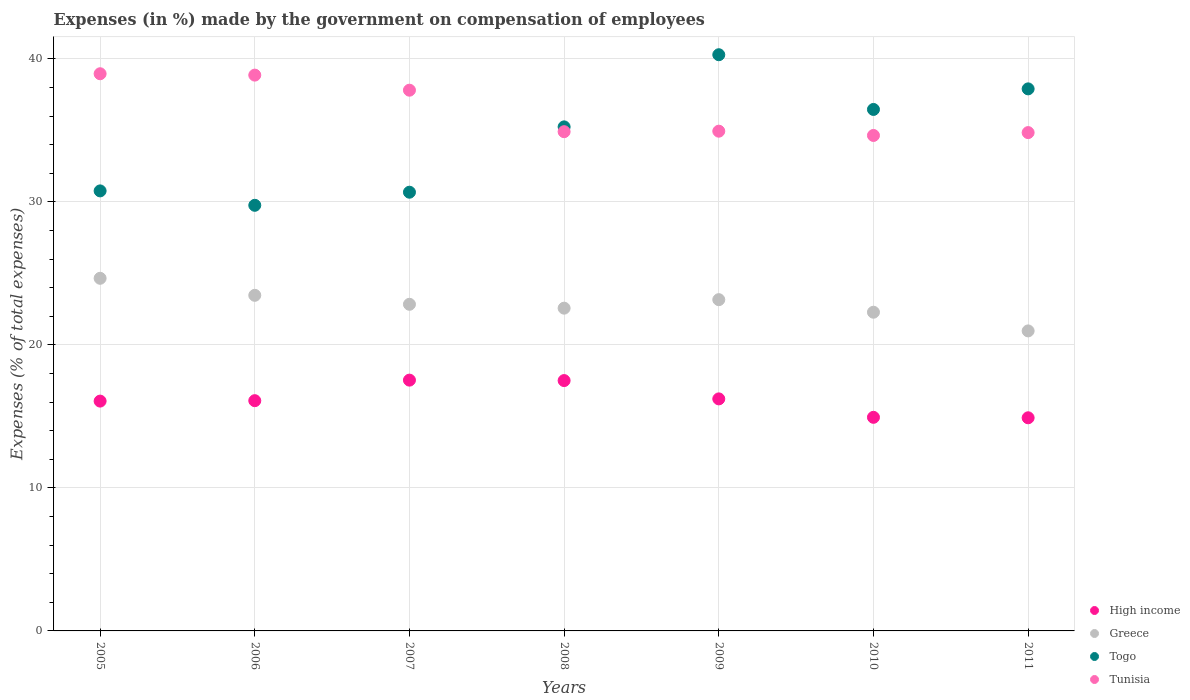How many different coloured dotlines are there?
Your response must be concise. 4. What is the percentage of expenses made by the government on compensation of employees in Greece in 2007?
Make the answer very short. 22.84. Across all years, what is the maximum percentage of expenses made by the government on compensation of employees in Togo?
Provide a succinct answer. 40.29. Across all years, what is the minimum percentage of expenses made by the government on compensation of employees in Tunisia?
Your response must be concise. 34.65. In which year was the percentage of expenses made by the government on compensation of employees in Greece maximum?
Give a very brief answer. 2005. What is the total percentage of expenses made by the government on compensation of employees in High income in the graph?
Offer a terse response. 113.28. What is the difference between the percentage of expenses made by the government on compensation of employees in Togo in 2007 and that in 2011?
Offer a very short reply. -7.23. What is the difference between the percentage of expenses made by the government on compensation of employees in Tunisia in 2008 and the percentage of expenses made by the government on compensation of employees in High income in 2007?
Offer a very short reply. 17.37. What is the average percentage of expenses made by the government on compensation of employees in Tunisia per year?
Make the answer very short. 36.43. In the year 2010, what is the difference between the percentage of expenses made by the government on compensation of employees in High income and percentage of expenses made by the government on compensation of employees in Tunisia?
Keep it short and to the point. -19.71. What is the ratio of the percentage of expenses made by the government on compensation of employees in Tunisia in 2007 to that in 2010?
Your answer should be compact. 1.09. What is the difference between the highest and the second highest percentage of expenses made by the government on compensation of employees in High income?
Keep it short and to the point. 0.03. What is the difference between the highest and the lowest percentage of expenses made by the government on compensation of employees in Tunisia?
Your answer should be compact. 4.32. In how many years, is the percentage of expenses made by the government on compensation of employees in Tunisia greater than the average percentage of expenses made by the government on compensation of employees in Tunisia taken over all years?
Provide a short and direct response. 3. Is it the case that in every year, the sum of the percentage of expenses made by the government on compensation of employees in High income and percentage of expenses made by the government on compensation of employees in Togo  is greater than the percentage of expenses made by the government on compensation of employees in Greece?
Keep it short and to the point. Yes. Is the percentage of expenses made by the government on compensation of employees in Greece strictly greater than the percentage of expenses made by the government on compensation of employees in Togo over the years?
Your answer should be very brief. No. How many dotlines are there?
Ensure brevity in your answer.  4. How many years are there in the graph?
Give a very brief answer. 7. Does the graph contain grids?
Your answer should be very brief. Yes. Where does the legend appear in the graph?
Your response must be concise. Bottom right. How are the legend labels stacked?
Give a very brief answer. Vertical. What is the title of the graph?
Provide a short and direct response. Expenses (in %) made by the government on compensation of employees. Does "Kosovo" appear as one of the legend labels in the graph?
Ensure brevity in your answer.  No. What is the label or title of the Y-axis?
Offer a very short reply. Expenses (% of total expenses). What is the Expenses (% of total expenses) in High income in 2005?
Provide a short and direct response. 16.07. What is the Expenses (% of total expenses) of Greece in 2005?
Give a very brief answer. 24.66. What is the Expenses (% of total expenses) in Togo in 2005?
Offer a very short reply. 30.77. What is the Expenses (% of total expenses) of Tunisia in 2005?
Your answer should be compact. 38.96. What is the Expenses (% of total expenses) in High income in 2006?
Your response must be concise. 16.1. What is the Expenses (% of total expenses) in Greece in 2006?
Offer a very short reply. 23.47. What is the Expenses (% of total expenses) in Togo in 2006?
Give a very brief answer. 29.76. What is the Expenses (% of total expenses) of Tunisia in 2006?
Provide a short and direct response. 38.86. What is the Expenses (% of total expenses) of High income in 2007?
Ensure brevity in your answer.  17.54. What is the Expenses (% of total expenses) of Greece in 2007?
Make the answer very short. 22.84. What is the Expenses (% of total expenses) of Togo in 2007?
Your answer should be compact. 30.68. What is the Expenses (% of total expenses) of Tunisia in 2007?
Provide a short and direct response. 37.81. What is the Expenses (% of total expenses) of High income in 2008?
Offer a terse response. 17.51. What is the Expenses (% of total expenses) of Greece in 2008?
Offer a terse response. 22.57. What is the Expenses (% of total expenses) in Togo in 2008?
Keep it short and to the point. 35.25. What is the Expenses (% of total expenses) in Tunisia in 2008?
Provide a succinct answer. 34.91. What is the Expenses (% of total expenses) in High income in 2009?
Keep it short and to the point. 16.23. What is the Expenses (% of total expenses) in Greece in 2009?
Your answer should be compact. 23.16. What is the Expenses (% of total expenses) in Togo in 2009?
Your response must be concise. 40.29. What is the Expenses (% of total expenses) in Tunisia in 2009?
Give a very brief answer. 34.94. What is the Expenses (% of total expenses) in High income in 2010?
Make the answer very short. 14.94. What is the Expenses (% of total expenses) of Greece in 2010?
Your answer should be compact. 22.29. What is the Expenses (% of total expenses) in Togo in 2010?
Give a very brief answer. 36.46. What is the Expenses (% of total expenses) in Tunisia in 2010?
Offer a very short reply. 34.65. What is the Expenses (% of total expenses) of High income in 2011?
Provide a short and direct response. 14.9. What is the Expenses (% of total expenses) of Greece in 2011?
Make the answer very short. 20.98. What is the Expenses (% of total expenses) of Togo in 2011?
Your answer should be very brief. 37.9. What is the Expenses (% of total expenses) of Tunisia in 2011?
Your answer should be compact. 34.85. Across all years, what is the maximum Expenses (% of total expenses) in High income?
Your answer should be very brief. 17.54. Across all years, what is the maximum Expenses (% of total expenses) in Greece?
Provide a short and direct response. 24.66. Across all years, what is the maximum Expenses (% of total expenses) in Togo?
Your response must be concise. 40.29. Across all years, what is the maximum Expenses (% of total expenses) in Tunisia?
Provide a succinct answer. 38.96. Across all years, what is the minimum Expenses (% of total expenses) of High income?
Your response must be concise. 14.9. Across all years, what is the minimum Expenses (% of total expenses) in Greece?
Your response must be concise. 20.98. Across all years, what is the minimum Expenses (% of total expenses) of Togo?
Your response must be concise. 29.76. Across all years, what is the minimum Expenses (% of total expenses) in Tunisia?
Ensure brevity in your answer.  34.65. What is the total Expenses (% of total expenses) in High income in the graph?
Offer a terse response. 113.28. What is the total Expenses (% of total expenses) in Greece in the graph?
Your answer should be very brief. 159.96. What is the total Expenses (% of total expenses) in Togo in the graph?
Give a very brief answer. 241.11. What is the total Expenses (% of total expenses) of Tunisia in the graph?
Ensure brevity in your answer.  254.98. What is the difference between the Expenses (% of total expenses) in High income in 2005 and that in 2006?
Provide a short and direct response. -0.03. What is the difference between the Expenses (% of total expenses) in Greece in 2005 and that in 2006?
Offer a very short reply. 1.19. What is the difference between the Expenses (% of total expenses) of Togo in 2005 and that in 2006?
Your answer should be compact. 1.01. What is the difference between the Expenses (% of total expenses) in Tunisia in 2005 and that in 2006?
Give a very brief answer. 0.1. What is the difference between the Expenses (% of total expenses) of High income in 2005 and that in 2007?
Provide a succinct answer. -1.47. What is the difference between the Expenses (% of total expenses) of Greece in 2005 and that in 2007?
Keep it short and to the point. 1.82. What is the difference between the Expenses (% of total expenses) of Togo in 2005 and that in 2007?
Ensure brevity in your answer.  0.09. What is the difference between the Expenses (% of total expenses) in Tunisia in 2005 and that in 2007?
Your response must be concise. 1.15. What is the difference between the Expenses (% of total expenses) of High income in 2005 and that in 2008?
Provide a succinct answer. -1.44. What is the difference between the Expenses (% of total expenses) of Greece in 2005 and that in 2008?
Your response must be concise. 2.09. What is the difference between the Expenses (% of total expenses) of Togo in 2005 and that in 2008?
Provide a short and direct response. -4.48. What is the difference between the Expenses (% of total expenses) of Tunisia in 2005 and that in 2008?
Your answer should be compact. 4.05. What is the difference between the Expenses (% of total expenses) of High income in 2005 and that in 2009?
Provide a succinct answer. -0.16. What is the difference between the Expenses (% of total expenses) of Greece in 2005 and that in 2009?
Ensure brevity in your answer.  1.49. What is the difference between the Expenses (% of total expenses) of Togo in 2005 and that in 2009?
Offer a very short reply. -9.52. What is the difference between the Expenses (% of total expenses) in Tunisia in 2005 and that in 2009?
Provide a succinct answer. 4.02. What is the difference between the Expenses (% of total expenses) of High income in 2005 and that in 2010?
Make the answer very short. 1.13. What is the difference between the Expenses (% of total expenses) in Greece in 2005 and that in 2010?
Ensure brevity in your answer.  2.37. What is the difference between the Expenses (% of total expenses) of Togo in 2005 and that in 2010?
Keep it short and to the point. -5.7. What is the difference between the Expenses (% of total expenses) in Tunisia in 2005 and that in 2010?
Ensure brevity in your answer.  4.32. What is the difference between the Expenses (% of total expenses) of High income in 2005 and that in 2011?
Give a very brief answer. 1.17. What is the difference between the Expenses (% of total expenses) in Greece in 2005 and that in 2011?
Provide a short and direct response. 3.68. What is the difference between the Expenses (% of total expenses) of Togo in 2005 and that in 2011?
Offer a very short reply. -7.13. What is the difference between the Expenses (% of total expenses) in Tunisia in 2005 and that in 2011?
Offer a very short reply. 4.12. What is the difference between the Expenses (% of total expenses) in High income in 2006 and that in 2007?
Give a very brief answer. -1.44. What is the difference between the Expenses (% of total expenses) in Greece in 2006 and that in 2007?
Make the answer very short. 0.63. What is the difference between the Expenses (% of total expenses) in Togo in 2006 and that in 2007?
Keep it short and to the point. -0.92. What is the difference between the Expenses (% of total expenses) of Tunisia in 2006 and that in 2007?
Provide a short and direct response. 1.05. What is the difference between the Expenses (% of total expenses) of High income in 2006 and that in 2008?
Your answer should be compact. -1.41. What is the difference between the Expenses (% of total expenses) in Greece in 2006 and that in 2008?
Your answer should be very brief. 0.9. What is the difference between the Expenses (% of total expenses) in Togo in 2006 and that in 2008?
Ensure brevity in your answer.  -5.48. What is the difference between the Expenses (% of total expenses) in Tunisia in 2006 and that in 2008?
Offer a very short reply. 3.96. What is the difference between the Expenses (% of total expenses) in High income in 2006 and that in 2009?
Give a very brief answer. -0.12. What is the difference between the Expenses (% of total expenses) of Greece in 2006 and that in 2009?
Keep it short and to the point. 0.3. What is the difference between the Expenses (% of total expenses) of Togo in 2006 and that in 2009?
Keep it short and to the point. -10.53. What is the difference between the Expenses (% of total expenses) of Tunisia in 2006 and that in 2009?
Provide a succinct answer. 3.92. What is the difference between the Expenses (% of total expenses) of High income in 2006 and that in 2010?
Give a very brief answer. 1.16. What is the difference between the Expenses (% of total expenses) of Greece in 2006 and that in 2010?
Keep it short and to the point. 1.18. What is the difference between the Expenses (% of total expenses) in Togo in 2006 and that in 2010?
Your answer should be compact. -6.7. What is the difference between the Expenses (% of total expenses) in Tunisia in 2006 and that in 2010?
Give a very brief answer. 4.22. What is the difference between the Expenses (% of total expenses) in High income in 2006 and that in 2011?
Ensure brevity in your answer.  1.2. What is the difference between the Expenses (% of total expenses) of Greece in 2006 and that in 2011?
Make the answer very short. 2.49. What is the difference between the Expenses (% of total expenses) of Togo in 2006 and that in 2011?
Keep it short and to the point. -8.14. What is the difference between the Expenses (% of total expenses) of Tunisia in 2006 and that in 2011?
Give a very brief answer. 4.02. What is the difference between the Expenses (% of total expenses) of High income in 2007 and that in 2008?
Keep it short and to the point. 0.03. What is the difference between the Expenses (% of total expenses) in Greece in 2007 and that in 2008?
Make the answer very short. 0.27. What is the difference between the Expenses (% of total expenses) in Togo in 2007 and that in 2008?
Your answer should be compact. -4.57. What is the difference between the Expenses (% of total expenses) of Tunisia in 2007 and that in 2008?
Ensure brevity in your answer.  2.9. What is the difference between the Expenses (% of total expenses) of High income in 2007 and that in 2009?
Provide a short and direct response. 1.31. What is the difference between the Expenses (% of total expenses) of Greece in 2007 and that in 2009?
Offer a terse response. -0.32. What is the difference between the Expenses (% of total expenses) of Togo in 2007 and that in 2009?
Provide a succinct answer. -9.61. What is the difference between the Expenses (% of total expenses) of Tunisia in 2007 and that in 2009?
Ensure brevity in your answer.  2.87. What is the difference between the Expenses (% of total expenses) of High income in 2007 and that in 2010?
Provide a short and direct response. 2.6. What is the difference between the Expenses (% of total expenses) in Greece in 2007 and that in 2010?
Ensure brevity in your answer.  0.55. What is the difference between the Expenses (% of total expenses) in Togo in 2007 and that in 2010?
Give a very brief answer. -5.79. What is the difference between the Expenses (% of total expenses) of Tunisia in 2007 and that in 2010?
Your response must be concise. 3.17. What is the difference between the Expenses (% of total expenses) of High income in 2007 and that in 2011?
Make the answer very short. 2.63. What is the difference between the Expenses (% of total expenses) of Greece in 2007 and that in 2011?
Offer a terse response. 1.86. What is the difference between the Expenses (% of total expenses) in Togo in 2007 and that in 2011?
Your response must be concise. -7.23. What is the difference between the Expenses (% of total expenses) in Tunisia in 2007 and that in 2011?
Ensure brevity in your answer.  2.97. What is the difference between the Expenses (% of total expenses) in High income in 2008 and that in 2009?
Your answer should be very brief. 1.28. What is the difference between the Expenses (% of total expenses) in Greece in 2008 and that in 2009?
Provide a short and direct response. -0.59. What is the difference between the Expenses (% of total expenses) of Togo in 2008 and that in 2009?
Your answer should be compact. -5.04. What is the difference between the Expenses (% of total expenses) in Tunisia in 2008 and that in 2009?
Make the answer very short. -0.04. What is the difference between the Expenses (% of total expenses) of High income in 2008 and that in 2010?
Provide a short and direct response. 2.57. What is the difference between the Expenses (% of total expenses) in Greece in 2008 and that in 2010?
Provide a short and direct response. 0.28. What is the difference between the Expenses (% of total expenses) of Togo in 2008 and that in 2010?
Ensure brevity in your answer.  -1.22. What is the difference between the Expenses (% of total expenses) of Tunisia in 2008 and that in 2010?
Make the answer very short. 0.26. What is the difference between the Expenses (% of total expenses) in High income in 2008 and that in 2011?
Provide a short and direct response. 2.6. What is the difference between the Expenses (% of total expenses) in Greece in 2008 and that in 2011?
Ensure brevity in your answer.  1.59. What is the difference between the Expenses (% of total expenses) in Togo in 2008 and that in 2011?
Your response must be concise. -2.66. What is the difference between the Expenses (% of total expenses) of Tunisia in 2008 and that in 2011?
Offer a terse response. 0.06. What is the difference between the Expenses (% of total expenses) of High income in 2009 and that in 2010?
Your answer should be compact. 1.29. What is the difference between the Expenses (% of total expenses) in Greece in 2009 and that in 2010?
Your answer should be compact. 0.88. What is the difference between the Expenses (% of total expenses) in Togo in 2009 and that in 2010?
Make the answer very short. 3.83. What is the difference between the Expenses (% of total expenses) of Tunisia in 2009 and that in 2010?
Your response must be concise. 0.3. What is the difference between the Expenses (% of total expenses) of High income in 2009 and that in 2011?
Give a very brief answer. 1.32. What is the difference between the Expenses (% of total expenses) of Greece in 2009 and that in 2011?
Your answer should be compact. 2.18. What is the difference between the Expenses (% of total expenses) in Togo in 2009 and that in 2011?
Keep it short and to the point. 2.39. What is the difference between the Expenses (% of total expenses) of Tunisia in 2009 and that in 2011?
Your answer should be very brief. 0.1. What is the difference between the Expenses (% of total expenses) of High income in 2010 and that in 2011?
Give a very brief answer. 0.03. What is the difference between the Expenses (% of total expenses) in Greece in 2010 and that in 2011?
Provide a succinct answer. 1.31. What is the difference between the Expenses (% of total expenses) of Togo in 2010 and that in 2011?
Your answer should be compact. -1.44. What is the difference between the Expenses (% of total expenses) of Tunisia in 2010 and that in 2011?
Give a very brief answer. -0.2. What is the difference between the Expenses (% of total expenses) in High income in 2005 and the Expenses (% of total expenses) in Greece in 2006?
Provide a succinct answer. -7.4. What is the difference between the Expenses (% of total expenses) of High income in 2005 and the Expenses (% of total expenses) of Togo in 2006?
Keep it short and to the point. -13.69. What is the difference between the Expenses (% of total expenses) in High income in 2005 and the Expenses (% of total expenses) in Tunisia in 2006?
Your answer should be compact. -22.8. What is the difference between the Expenses (% of total expenses) of Greece in 2005 and the Expenses (% of total expenses) of Togo in 2006?
Keep it short and to the point. -5.1. What is the difference between the Expenses (% of total expenses) of Greece in 2005 and the Expenses (% of total expenses) of Tunisia in 2006?
Your answer should be compact. -14.21. What is the difference between the Expenses (% of total expenses) of Togo in 2005 and the Expenses (% of total expenses) of Tunisia in 2006?
Your answer should be compact. -8.1. What is the difference between the Expenses (% of total expenses) in High income in 2005 and the Expenses (% of total expenses) in Greece in 2007?
Give a very brief answer. -6.77. What is the difference between the Expenses (% of total expenses) in High income in 2005 and the Expenses (% of total expenses) in Togo in 2007?
Ensure brevity in your answer.  -14.61. What is the difference between the Expenses (% of total expenses) in High income in 2005 and the Expenses (% of total expenses) in Tunisia in 2007?
Ensure brevity in your answer.  -21.74. What is the difference between the Expenses (% of total expenses) of Greece in 2005 and the Expenses (% of total expenses) of Togo in 2007?
Give a very brief answer. -6.02. What is the difference between the Expenses (% of total expenses) in Greece in 2005 and the Expenses (% of total expenses) in Tunisia in 2007?
Make the answer very short. -13.15. What is the difference between the Expenses (% of total expenses) in Togo in 2005 and the Expenses (% of total expenses) in Tunisia in 2007?
Offer a terse response. -7.04. What is the difference between the Expenses (% of total expenses) in High income in 2005 and the Expenses (% of total expenses) in Greece in 2008?
Provide a succinct answer. -6.5. What is the difference between the Expenses (% of total expenses) of High income in 2005 and the Expenses (% of total expenses) of Togo in 2008?
Offer a terse response. -19.18. What is the difference between the Expenses (% of total expenses) of High income in 2005 and the Expenses (% of total expenses) of Tunisia in 2008?
Offer a very short reply. -18.84. What is the difference between the Expenses (% of total expenses) in Greece in 2005 and the Expenses (% of total expenses) in Togo in 2008?
Your answer should be compact. -10.59. What is the difference between the Expenses (% of total expenses) of Greece in 2005 and the Expenses (% of total expenses) of Tunisia in 2008?
Your response must be concise. -10.25. What is the difference between the Expenses (% of total expenses) in Togo in 2005 and the Expenses (% of total expenses) in Tunisia in 2008?
Keep it short and to the point. -4.14. What is the difference between the Expenses (% of total expenses) of High income in 2005 and the Expenses (% of total expenses) of Greece in 2009?
Your response must be concise. -7.09. What is the difference between the Expenses (% of total expenses) in High income in 2005 and the Expenses (% of total expenses) in Togo in 2009?
Keep it short and to the point. -24.22. What is the difference between the Expenses (% of total expenses) of High income in 2005 and the Expenses (% of total expenses) of Tunisia in 2009?
Offer a very short reply. -18.87. What is the difference between the Expenses (% of total expenses) in Greece in 2005 and the Expenses (% of total expenses) in Togo in 2009?
Your answer should be very brief. -15.63. What is the difference between the Expenses (% of total expenses) in Greece in 2005 and the Expenses (% of total expenses) in Tunisia in 2009?
Offer a terse response. -10.29. What is the difference between the Expenses (% of total expenses) in Togo in 2005 and the Expenses (% of total expenses) in Tunisia in 2009?
Your response must be concise. -4.18. What is the difference between the Expenses (% of total expenses) in High income in 2005 and the Expenses (% of total expenses) in Greece in 2010?
Ensure brevity in your answer.  -6.22. What is the difference between the Expenses (% of total expenses) in High income in 2005 and the Expenses (% of total expenses) in Togo in 2010?
Offer a very short reply. -20.39. What is the difference between the Expenses (% of total expenses) of High income in 2005 and the Expenses (% of total expenses) of Tunisia in 2010?
Keep it short and to the point. -18.58. What is the difference between the Expenses (% of total expenses) of Greece in 2005 and the Expenses (% of total expenses) of Togo in 2010?
Your response must be concise. -11.81. What is the difference between the Expenses (% of total expenses) of Greece in 2005 and the Expenses (% of total expenses) of Tunisia in 2010?
Give a very brief answer. -9.99. What is the difference between the Expenses (% of total expenses) in Togo in 2005 and the Expenses (% of total expenses) in Tunisia in 2010?
Give a very brief answer. -3.88. What is the difference between the Expenses (% of total expenses) in High income in 2005 and the Expenses (% of total expenses) in Greece in 2011?
Offer a very short reply. -4.91. What is the difference between the Expenses (% of total expenses) in High income in 2005 and the Expenses (% of total expenses) in Togo in 2011?
Your answer should be compact. -21.83. What is the difference between the Expenses (% of total expenses) of High income in 2005 and the Expenses (% of total expenses) of Tunisia in 2011?
Offer a very short reply. -18.78. What is the difference between the Expenses (% of total expenses) in Greece in 2005 and the Expenses (% of total expenses) in Togo in 2011?
Give a very brief answer. -13.25. What is the difference between the Expenses (% of total expenses) of Greece in 2005 and the Expenses (% of total expenses) of Tunisia in 2011?
Your answer should be very brief. -10.19. What is the difference between the Expenses (% of total expenses) of Togo in 2005 and the Expenses (% of total expenses) of Tunisia in 2011?
Offer a terse response. -4.08. What is the difference between the Expenses (% of total expenses) in High income in 2006 and the Expenses (% of total expenses) in Greece in 2007?
Give a very brief answer. -6.74. What is the difference between the Expenses (% of total expenses) of High income in 2006 and the Expenses (% of total expenses) of Togo in 2007?
Your answer should be compact. -14.58. What is the difference between the Expenses (% of total expenses) in High income in 2006 and the Expenses (% of total expenses) in Tunisia in 2007?
Provide a short and direct response. -21.71. What is the difference between the Expenses (% of total expenses) of Greece in 2006 and the Expenses (% of total expenses) of Togo in 2007?
Provide a short and direct response. -7.21. What is the difference between the Expenses (% of total expenses) of Greece in 2006 and the Expenses (% of total expenses) of Tunisia in 2007?
Your response must be concise. -14.34. What is the difference between the Expenses (% of total expenses) in Togo in 2006 and the Expenses (% of total expenses) in Tunisia in 2007?
Provide a succinct answer. -8.05. What is the difference between the Expenses (% of total expenses) of High income in 2006 and the Expenses (% of total expenses) of Greece in 2008?
Keep it short and to the point. -6.47. What is the difference between the Expenses (% of total expenses) of High income in 2006 and the Expenses (% of total expenses) of Togo in 2008?
Your answer should be very brief. -19.15. What is the difference between the Expenses (% of total expenses) of High income in 2006 and the Expenses (% of total expenses) of Tunisia in 2008?
Offer a terse response. -18.81. What is the difference between the Expenses (% of total expenses) of Greece in 2006 and the Expenses (% of total expenses) of Togo in 2008?
Ensure brevity in your answer.  -11.78. What is the difference between the Expenses (% of total expenses) of Greece in 2006 and the Expenses (% of total expenses) of Tunisia in 2008?
Your response must be concise. -11.44. What is the difference between the Expenses (% of total expenses) in Togo in 2006 and the Expenses (% of total expenses) in Tunisia in 2008?
Your response must be concise. -5.15. What is the difference between the Expenses (% of total expenses) of High income in 2006 and the Expenses (% of total expenses) of Greece in 2009?
Make the answer very short. -7.06. What is the difference between the Expenses (% of total expenses) of High income in 2006 and the Expenses (% of total expenses) of Togo in 2009?
Make the answer very short. -24.19. What is the difference between the Expenses (% of total expenses) of High income in 2006 and the Expenses (% of total expenses) of Tunisia in 2009?
Your response must be concise. -18.84. What is the difference between the Expenses (% of total expenses) in Greece in 2006 and the Expenses (% of total expenses) in Togo in 2009?
Your response must be concise. -16.82. What is the difference between the Expenses (% of total expenses) of Greece in 2006 and the Expenses (% of total expenses) of Tunisia in 2009?
Provide a succinct answer. -11.48. What is the difference between the Expenses (% of total expenses) of Togo in 2006 and the Expenses (% of total expenses) of Tunisia in 2009?
Your response must be concise. -5.18. What is the difference between the Expenses (% of total expenses) in High income in 2006 and the Expenses (% of total expenses) in Greece in 2010?
Provide a succinct answer. -6.19. What is the difference between the Expenses (% of total expenses) of High income in 2006 and the Expenses (% of total expenses) of Togo in 2010?
Provide a succinct answer. -20.36. What is the difference between the Expenses (% of total expenses) in High income in 2006 and the Expenses (% of total expenses) in Tunisia in 2010?
Keep it short and to the point. -18.55. What is the difference between the Expenses (% of total expenses) of Greece in 2006 and the Expenses (% of total expenses) of Togo in 2010?
Offer a terse response. -13. What is the difference between the Expenses (% of total expenses) of Greece in 2006 and the Expenses (% of total expenses) of Tunisia in 2010?
Provide a succinct answer. -11.18. What is the difference between the Expenses (% of total expenses) of Togo in 2006 and the Expenses (% of total expenses) of Tunisia in 2010?
Your answer should be very brief. -4.88. What is the difference between the Expenses (% of total expenses) in High income in 2006 and the Expenses (% of total expenses) in Greece in 2011?
Provide a succinct answer. -4.88. What is the difference between the Expenses (% of total expenses) of High income in 2006 and the Expenses (% of total expenses) of Togo in 2011?
Ensure brevity in your answer.  -21.8. What is the difference between the Expenses (% of total expenses) in High income in 2006 and the Expenses (% of total expenses) in Tunisia in 2011?
Provide a succinct answer. -18.75. What is the difference between the Expenses (% of total expenses) of Greece in 2006 and the Expenses (% of total expenses) of Togo in 2011?
Your answer should be compact. -14.44. What is the difference between the Expenses (% of total expenses) in Greece in 2006 and the Expenses (% of total expenses) in Tunisia in 2011?
Ensure brevity in your answer.  -11.38. What is the difference between the Expenses (% of total expenses) of Togo in 2006 and the Expenses (% of total expenses) of Tunisia in 2011?
Provide a succinct answer. -5.08. What is the difference between the Expenses (% of total expenses) in High income in 2007 and the Expenses (% of total expenses) in Greece in 2008?
Your answer should be compact. -5.03. What is the difference between the Expenses (% of total expenses) of High income in 2007 and the Expenses (% of total expenses) of Togo in 2008?
Your answer should be very brief. -17.71. What is the difference between the Expenses (% of total expenses) of High income in 2007 and the Expenses (% of total expenses) of Tunisia in 2008?
Give a very brief answer. -17.37. What is the difference between the Expenses (% of total expenses) of Greece in 2007 and the Expenses (% of total expenses) of Togo in 2008?
Ensure brevity in your answer.  -12.41. What is the difference between the Expenses (% of total expenses) of Greece in 2007 and the Expenses (% of total expenses) of Tunisia in 2008?
Your response must be concise. -12.07. What is the difference between the Expenses (% of total expenses) in Togo in 2007 and the Expenses (% of total expenses) in Tunisia in 2008?
Keep it short and to the point. -4.23. What is the difference between the Expenses (% of total expenses) in High income in 2007 and the Expenses (% of total expenses) in Greece in 2009?
Make the answer very short. -5.63. What is the difference between the Expenses (% of total expenses) of High income in 2007 and the Expenses (% of total expenses) of Togo in 2009?
Your answer should be very brief. -22.75. What is the difference between the Expenses (% of total expenses) of High income in 2007 and the Expenses (% of total expenses) of Tunisia in 2009?
Provide a short and direct response. -17.41. What is the difference between the Expenses (% of total expenses) of Greece in 2007 and the Expenses (% of total expenses) of Togo in 2009?
Your response must be concise. -17.45. What is the difference between the Expenses (% of total expenses) of Greece in 2007 and the Expenses (% of total expenses) of Tunisia in 2009?
Your answer should be compact. -12.1. What is the difference between the Expenses (% of total expenses) in Togo in 2007 and the Expenses (% of total expenses) in Tunisia in 2009?
Offer a very short reply. -4.27. What is the difference between the Expenses (% of total expenses) in High income in 2007 and the Expenses (% of total expenses) in Greece in 2010?
Keep it short and to the point. -4.75. What is the difference between the Expenses (% of total expenses) of High income in 2007 and the Expenses (% of total expenses) of Togo in 2010?
Your answer should be very brief. -18.93. What is the difference between the Expenses (% of total expenses) of High income in 2007 and the Expenses (% of total expenses) of Tunisia in 2010?
Give a very brief answer. -17.11. What is the difference between the Expenses (% of total expenses) of Greece in 2007 and the Expenses (% of total expenses) of Togo in 2010?
Ensure brevity in your answer.  -13.62. What is the difference between the Expenses (% of total expenses) of Greece in 2007 and the Expenses (% of total expenses) of Tunisia in 2010?
Offer a very short reply. -11.81. What is the difference between the Expenses (% of total expenses) of Togo in 2007 and the Expenses (% of total expenses) of Tunisia in 2010?
Make the answer very short. -3.97. What is the difference between the Expenses (% of total expenses) in High income in 2007 and the Expenses (% of total expenses) in Greece in 2011?
Provide a succinct answer. -3.44. What is the difference between the Expenses (% of total expenses) in High income in 2007 and the Expenses (% of total expenses) in Togo in 2011?
Your answer should be compact. -20.37. What is the difference between the Expenses (% of total expenses) in High income in 2007 and the Expenses (% of total expenses) in Tunisia in 2011?
Your answer should be compact. -17.31. What is the difference between the Expenses (% of total expenses) in Greece in 2007 and the Expenses (% of total expenses) in Togo in 2011?
Your answer should be compact. -15.06. What is the difference between the Expenses (% of total expenses) in Greece in 2007 and the Expenses (% of total expenses) in Tunisia in 2011?
Ensure brevity in your answer.  -12.01. What is the difference between the Expenses (% of total expenses) of Togo in 2007 and the Expenses (% of total expenses) of Tunisia in 2011?
Keep it short and to the point. -4.17. What is the difference between the Expenses (% of total expenses) of High income in 2008 and the Expenses (% of total expenses) of Greece in 2009?
Your response must be concise. -5.66. What is the difference between the Expenses (% of total expenses) of High income in 2008 and the Expenses (% of total expenses) of Togo in 2009?
Keep it short and to the point. -22.79. What is the difference between the Expenses (% of total expenses) in High income in 2008 and the Expenses (% of total expenses) in Tunisia in 2009?
Ensure brevity in your answer.  -17.44. What is the difference between the Expenses (% of total expenses) of Greece in 2008 and the Expenses (% of total expenses) of Togo in 2009?
Your response must be concise. -17.72. What is the difference between the Expenses (% of total expenses) of Greece in 2008 and the Expenses (% of total expenses) of Tunisia in 2009?
Give a very brief answer. -12.38. What is the difference between the Expenses (% of total expenses) in Togo in 2008 and the Expenses (% of total expenses) in Tunisia in 2009?
Keep it short and to the point. 0.3. What is the difference between the Expenses (% of total expenses) of High income in 2008 and the Expenses (% of total expenses) of Greece in 2010?
Your answer should be compact. -4.78. What is the difference between the Expenses (% of total expenses) of High income in 2008 and the Expenses (% of total expenses) of Togo in 2010?
Your response must be concise. -18.96. What is the difference between the Expenses (% of total expenses) of High income in 2008 and the Expenses (% of total expenses) of Tunisia in 2010?
Offer a very short reply. -17.14. What is the difference between the Expenses (% of total expenses) in Greece in 2008 and the Expenses (% of total expenses) in Togo in 2010?
Your answer should be very brief. -13.9. What is the difference between the Expenses (% of total expenses) in Greece in 2008 and the Expenses (% of total expenses) in Tunisia in 2010?
Provide a short and direct response. -12.08. What is the difference between the Expenses (% of total expenses) of Togo in 2008 and the Expenses (% of total expenses) of Tunisia in 2010?
Provide a succinct answer. 0.6. What is the difference between the Expenses (% of total expenses) in High income in 2008 and the Expenses (% of total expenses) in Greece in 2011?
Keep it short and to the point. -3.47. What is the difference between the Expenses (% of total expenses) in High income in 2008 and the Expenses (% of total expenses) in Togo in 2011?
Your response must be concise. -20.4. What is the difference between the Expenses (% of total expenses) of High income in 2008 and the Expenses (% of total expenses) of Tunisia in 2011?
Your answer should be very brief. -17.34. What is the difference between the Expenses (% of total expenses) in Greece in 2008 and the Expenses (% of total expenses) in Togo in 2011?
Make the answer very short. -15.33. What is the difference between the Expenses (% of total expenses) in Greece in 2008 and the Expenses (% of total expenses) in Tunisia in 2011?
Make the answer very short. -12.28. What is the difference between the Expenses (% of total expenses) in Togo in 2008 and the Expenses (% of total expenses) in Tunisia in 2011?
Make the answer very short. 0.4. What is the difference between the Expenses (% of total expenses) of High income in 2009 and the Expenses (% of total expenses) of Greece in 2010?
Keep it short and to the point. -6.06. What is the difference between the Expenses (% of total expenses) in High income in 2009 and the Expenses (% of total expenses) in Togo in 2010?
Keep it short and to the point. -20.24. What is the difference between the Expenses (% of total expenses) in High income in 2009 and the Expenses (% of total expenses) in Tunisia in 2010?
Offer a terse response. -18.42. What is the difference between the Expenses (% of total expenses) of Greece in 2009 and the Expenses (% of total expenses) of Togo in 2010?
Your answer should be very brief. -13.3. What is the difference between the Expenses (% of total expenses) in Greece in 2009 and the Expenses (% of total expenses) in Tunisia in 2010?
Your answer should be compact. -11.48. What is the difference between the Expenses (% of total expenses) of Togo in 2009 and the Expenses (% of total expenses) of Tunisia in 2010?
Provide a succinct answer. 5.65. What is the difference between the Expenses (% of total expenses) in High income in 2009 and the Expenses (% of total expenses) in Greece in 2011?
Give a very brief answer. -4.75. What is the difference between the Expenses (% of total expenses) of High income in 2009 and the Expenses (% of total expenses) of Togo in 2011?
Your answer should be very brief. -21.68. What is the difference between the Expenses (% of total expenses) in High income in 2009 and the Expenses (% of total expenses) in Tunisia in 2011?
Your answer should be compact. -18.62. What is the difference between the Expenses (% of total expenses) of Greece in 2009 and the Expenses (% of total expenses) of Togo in 2011?
Make the answer very short. -14.74. What is the difference between the Expenses (% of total expenses) of Greece in 2009 and the Expenses (% of total expenses) of Tunisia in 2011?
Provide a short and direct response. -11.68. What is the difference between the Expenses (% of total expenses) in Togo in 2009 and the Expenses (% of total expenses) in Tunisia in 2011?
Keep it short and to the point. 5.45. What is the difference between the Expenses (% of total expenses) of High income in 2010 and the Expenses (% of total expenses) of Greece in 2011?
Offer a terse response. -6.04. What is the difference between the Expenses (% of total expenses) of High income in 2010 and the Expenses (% of total expenses) of Togo in 2011?
Make the answer very short. -22.97. What is the difference between the Expenses (% of total expenses) in High income in 2010 and the Expenses (% of total expenses) in Tunisia in 2011?
Your answer should be compact. -19.91. What is the difference between the Expenses (% of total expenses) of Greece in 2010 and the Expenses (% of total expenses) of Togo in 2011?
Offer a very short reply. -15.62. What is the difference between the Expenses (% of total expenses) of Greece in 2010 and the Expenses (% of total expenses) of Tunisia in 2011?
Keep it short and to the point. -12.56. What is the difference between the Expenses (% of total expenses) of Togo in 2010 and the Expenses (% of total expenses) of Tunisia in 2011?
Your answer should be very brief. 1.62. What is the average Expenses (% of total expenses) of High income per year?
Keep it short and to the point. 16.18. What is the average Expenses (% of total expenses) in Greece per year?
Your answer should be compact. 22.85. What is the average Expenses (% of total expenses) in Togo per year?
Your response must be concise. 34.44. What is the average Expenses (% of total expenses) in Tunisia per year?
Your answer should be compact. 36.43. In the year 2005, what is the difference between the Expenses (% of total expenses) of High income and Expenses (% of total expenses) of Greece?
Your response must be concise. -8.59. In the year 2005, what is the difference between the Expenses (% of total expenses) in High income and Expenses (% of total expenses) in Togo?
Keep it short and to the point. -14.7. In the year 2005, what is the difference between the Expenses (% of total expenses) of High income and Expenses (% of total expenses) of Tunisia?
Ensure brevity in your answer.  -22.89. In the year 2005, what is the difference between the Expenses (% of total expenses) in Greece and Expenses (% of total expenses) in Togo?
Give a very brief answer. -6.11. In the year 2005, what is the difference between the Expenses (% of total expenses) of Greece and Expenses (% of total expenses) of Tunisia?
Offer a very short reply. -14.3. In the year 2005, what is the difference between the Expenses (% of total expenses) of Togo and Expenses (% of total expenses) of Tunisia?
Provide a succinct answer. -8.19. In the year 2006, what is the difference between the Expenses (% of total expenses) of High income and Expenses (% of total expenses) of Greece?
Ensure brevity in your answer.  -7.37. In the year 2006, what is the difference between the Expenses (% of total expenses) of High income and Expenses (% of total expenses) of Togo?
Provide a succinct answer. -13.66. In the year 2006, what is the difference between the Expenses (% of total expenses) in High income and Expenses (% of total expenses) in Tunisia?
Your answer should be very brief. -22.77. In the year 2006, what is the difference between the Expenses (% of total expenses) in Greece and Expenses (% of total expenses) in Togo?
Ensure brevity in your answer.  -6.29. In the year 2006, what is the difference between the Expenses (% of total expenses) of Greece and Expenses (% of total expenses) of Tunisia?
Offer a very short reply. -15.4. In the year 2006, what is the difference between the Expenses (% of total expenses) of Togo and Expenses (% of total expenses) of Tunisia?
Ensure brevity in your answer.  -9.1. In the year 2007, what is the difference between the Expenses (% of total expenses) in High income and Expenses (% of total expenses) in Greece?
Keep it short and to the point. -5.3. In the year 2007, what is the difference between the Expenses (% of total expenses) in High income and Expenses (% of total expenses) in Togo?
Provide a short and direct response. -13.14. In the year 2007, what is the difference between the Expenses (% of total expenses) in High income and Expenses (% of total expenses) in Tunisia?
Provide a short and direct response. -20.27. In the year 2007, what is the difference between the Expenses (% of total expenses) in Greece and Expenses (% of total expenses) in Togo?
Your answer should be very brief. -7.84. In the year 2007, what is the difference between the Expenses (% of total expenses) in Greece and Expenses (% of total expenses) in Tunisia?
Ensure brevity in your answer.  -14.97. In the year 2007, what is the difference between the Expenses (% of total expenses) of Togo and Expenses (% of total expenses) of Tunisia?
Make the answer very short. -7.13. In the year 2008, what is the difference between the Expenses (% of total expenses) in High income and Expenses (% of total expenses) in Greece?
Provide a short and direct response. -5.06. In the year 2008, what is the difference between the Expenses (% of total expenses) of High income and Expenses (% of total expenses) of Togo?
Offer a very short reply. -17.74. In the year 2008, what is the difference between the Expenses (% of total expenses) of High income and Expenses (% of total expenses) of Tunisia?
Offer a terse response. -17.4. In the year 2008, what is the difference between the Expenses (% of total expenses) of Greece and Expenses (% of total expenses) of Togo?
Offer a terse response. -12.68. In the year 2008, what is the difference between the Expenses (% of total expenses) in Greece and Expenses (% of total expenses) in Tunisia?
Your answer should be compact. -12.34. In the year 2008, what is the difference between the Expenses (% of total expenses) in Togo and Expenses (% of total expenses) in Tunisia?
Ensure brevity in your answer.  0.34. In the year 2009, what is the difference between the Expenses (% of total expenses) in High income and Expenses (% of total expenses) in Greece?
Your answer should be compact. -6.94. In the year 2009, what is the difference between the Expenses (% of total expenses) of High income and Expenses (% of total expenses) of Togo?
Your answer should be compact. -24.07. In the year 2009, what is the difference between the Expenses (% of total expenses) in High income and Expenses (% of total expenses) in Tunisia?
Make the answer very short. -18.72. In the year 2009, what is the difference between the Expenses (% of total expenses) in Greece and Expenses (% of total expenses) in Togo?
Offer a very short reply. -17.13. In the year 2009, what is the difference between the Expenses (% of total expenses) in Greece and Expenses (% of total expenses) in Tunisia?
Your answer should be compact. -11.78. In the year 2009, what is the difference between the Expenses (% of total expenses) in Togo and Expenses (% of total expenses) in Tunisia?
Offer a very short reply. 5.35. In the year 2010, what is the difference between the Expenses (% of total expenses) in High income and Expenses (% of total expenses) in Greece?
Provide a short and direct response. -7.35. In the year 2010, what is the difference between the Expenses (% of total expenses) in High income and Expenses (% of total expenses) in Togo?
Ensure brevity in your answer.  -21.53. In the year 2010, what is the difference between the Expenses (% of total expenses) in High income and Expenses (% of total expenses) in Tunisia?
Your answer should be compact. -19.71. In the year 2010, what is the difference between the Expenses (% of total expenses) in Greece and Expenses (% of total expenses) in Togo?
Offer a very short reply. -14.18. In the year 2010, what is the difference between the Expenses (% of total expenses) in Greece and Expenses (% of total expenses) in Tunisia?
Keep it short and to the point. -12.36. In the year 2010, what is the difference between the Expenses (% of total expenses) of Togo and Expenses (% of total expenses) of Tunisia?
Your response must be concise. 1.82. In the year 2011, what is the difference between the Expenses (% of total expenses) in High income and Expenses (% of total expenses) in Greece?
Provide a short and direct response. -6.08. In the year 2011, what is the difference between the Expenses (% of total expenses) in High income and Expenses (% of total expenses) in Togo?
Keep it short and to the point. -23. In the year 2011, what is the difference between the Expenses (% of total expenses) of High income and Expenses (% of total expenses) of Tunisia?
Your response must be concise. -19.94. In the year 2011, what is the difference between the Expenses (% of total expenses) of Greece and Expenses (% of total expenses) of Togo?
Your answer should be very brief. -16.92. In the year 2011, what is the difference between the Expenses (% of total expenses) of Greece and Expenses (% of total expenses) of Tunisia?
Offer a terse response. -13.87. In the year 2011, what is the difference between the Expenses (% of total expenses) in Togo and Expenses (% of total expenses) in Tunisia?
Your response must be concise. 3.06. What is the ratio of the Expenses (% of total expenses) of Greece in 2005 to that in 2006?
Give a very brief answer. 1.05. What is the ratio of the Expenses (% of total expenses) of Togo in 2005 to that in 2006?
Give a very brief answer. 1.03. What is the ratio of the Expenses (% of total expenses) of High income in 2005 to that in 2007?
Keep it short and to the point. 0.92. What is the ratio of the Expenses (% of total expenses) of Greece in 2005 to that in 2007?
Your answer should be compact. 1.08. What is the ratio of the Expenses (% of total expenses) of Togo in 2005 to that in 2007?
Keep it short and to the point. 1. What is the ratio of the Expenses (% of total expenses) in Tunisia in 2005 to that in 2007?
Keep it short and to the point. 1.03. What is the ratio of the Expenses (% of total expenses) in High income in 2005 to that in 2008?
Offer a very short reply. 0.92. What is the ratio of the Expenses (% of total expenses) in Greece in 2005 to that in 2008?
Make the answer very short. 1.09. What is the ratio of the Expenses (% of total expenses) of Togo in 2005 to that in 2008?
Make the answer very short. 0.87. What is the ratio of the Expenses (% of total expenses) in Tunisia in 2005 to that in 2008?
Offer a very short reply. 1.12. What is the ratio of the Expenses (% of total expenses) of Greece in 2005 to that in 2009?
Your response must be concise. 1.06. What is the ratio of the Expenses (% of total expenses) of Togo in 2005 to that in 2009?
Your answer should be compact. 0.76. What is the ratio of the Expenses (% of total expenses) in Tunisia in 2005 to that in 2009?
Your answer should be very brief. 1.11. What is the ratio of the Expenses (% of total expenses) in High income in 2005 to that in 2010?
Your response must be concise. 1.08. What is the ratio of the Expenses (% of total expenses) of Greece in 2005 to that in 2010?
Offer a terse response. 1.11. What is the ratio of the Expenses (% of total expenses) in Togo in 2005 to that in 2010?
Offer a terse response. 0.84. What is the ratio of the Expenses (% of total expenses) of Tunisia in 2005 to that in 2010?
Your answer should be compact. 1.12. What is the ratio of the Expenses (% of total expenses) in High income in 2005 to that in 2011?
Make the answer very short. 1.08. What is the ratio of the Expenses (% of total expenses) of Greece in 2005 to that in 2011?
Make the answer very short. 1.18. What is the ratio of the Expenses (% of total expenses) of Togo in 2005 to that in 2011?
Make the answer very short. 0.81. What is the ratio of the Expenses (% of total expenses) of Tunisia in 2005 to that in 2011?
Give a very brief answer. 1.12. What is the ratio of the Expenses (% of total expenses) in High income in 2006 to that in 2007?
Provide a short and direct response. 0.92. What is the ratio of the Expenses (% of total expenses) in Greece in 2006 to that in 2007?
Offer a terse response. 1.03. What is the ratio of the Expenses (% of total expenses) in Togo in 2006 to that in 2007?
Ensure brevity in your answer.  0.97. What is the ratio of the Expenses (% of total expenses) of Tunisia in 2006 to that in 2007?
Make the answer very short. 1.03. What is the ratio of the Expenses (% of total expenses) in High income in 2006 to that in 2008?
Provide a short and direct response. 0.92. What is the ratio of the Expenses (% of total expenses) in Greece in 2006 to that in 2008?
Make the answer very short. 1.04. What is the ratio of the Expenses (% of total expenses) of Togo in 2006 to that in 2008?
Offer a terse response. 0.84. What is the ratio of the Expenses (% of total expenses) in Tunisia in 2006 to that in 2008?
Make the answer very short. 1.11. What is the ratio of the Expenses (% of total expenses) of Greece in 2006 to that in 2009?
Offer a very short reply. 1.01. What is the ratio of the Expenses (% of total expenses) in Togo in 2006 to that in 2009?
Make the answer very short. 0.74. What is the ratio of the Expenses (% of total expenses) of Tunisia in 2006 to that in 2009?
Ensure brevity in your answer.  1.11. What is the ratio of the Expenses (% of total expenses) in High income in 2006 to that in 2010?
Provide a succinct answer. 1.08. What is the ratio of the Expenses (% of total expenses) in Greece in 2006 to that in 2010?
Give a very brief answer. 1.05. What is the ratio of the Expenses (% of total expenses) in Togo in 2006 to that in 2010?
Ensure brevity in your answer.  0.82. What is the ratio of the Expenses (% of total expenses) of Tunisia in 2006 to that in 2010?
Provide a short and direct response. 1.12. What is the ratio of the Expenses (% of total expenses) in High income in 2006 to that in 2011?
Ensure brevity in your answer.  1.08. What is the ratio of the Expenses (% of total expenses) of Greece in 2006 to that in 2011?
Provide a short and direct response. 1.12. What is the ratio of the Expenses (% of total expenses) of Togo in 2006 to that in 2011?
Your answer should be very brief. 0.79. What is the ratio of the Expenses (% of total expenses) of Tunisia in 2006 to that in 2011?
Ensure brevity in your answer.  1.12. What is the ratio of the Expenses (% of total expenses) in Greece in 2007 to that in 2008?
Make the answer very short. 1.01. What is the ratio of the Expenses (% of total expenses) in Togo in 2007 to that in 2008?
Your answer should be very brief. 0.87. What is the ratio of the Expenses (% of total expenses) of Tunisia in 2007 to that in 2008?
Provide a short and direct response. 1.08. What is the ratio of the Expenses (% of total expenses) in High income in 2007 to that in 2009?
Ensure brevity in your answer.  1.08. What is the ratio of the Expenses (% of total expenses) in Greece in 2007 to that in 2009?
Keep it short and to the point. 0.99. What is the ratio of the Expenses (% of total expenses) of Togo in 2007 to that in 2009?
Offer a terse response. 0.76. What is the ratio of the Expenses (% of total expenses) of Tunisia in 2007 to that in 2009?
Offer a terse response. 1.08. What is the ratio of the Expenses (% of total expenses) in High income in 2007 to that in 2010?
Your response must be concise. 1.17. What is the ratio of the Expenses (% of total expenses) in Greece in 2007 to that in 2010?
Your response must be concise. 1.02. What is the ratio of the Expenses (% of total expenses) of Togo in 2007 to that in 2010?
Your response must be concise. 0.84. What is the ratio of the Expenses (% of total expenses) of Tunisia in 2007 to that in 2010?
Give a very brief answer. 1.09. What is the ratio of the Expenses (% of total expenses) of High income in 2007 to that in 2011?
Ensure brevity in your answer.  1.18. What is the ratio of the Expenses (% of total expenses) of Greece in 2007 to that in 2011?
Give a very brief answer. 1.09. What is the ratio of the Expenses (% of total expenses) in Togo in 2007 to that in 2011?
Offer a very short reply. 0.81. What is the ratio of the Expenses (% of total expenses) in Tunisia in 2007 to that in 2011?
Give a very brief answer. 1.09. What is the ratio of the Expenses (% of total expenses) in High income in 2008 to that in 2009?
Provide a short and direct response. 1.08. What is the ratio of the Expenses (% of total expenses) of Greece in 2008 to that in 2009?
Offer a very short reply. 0.97. What is the ratio of the Expenses (% of total expenses) of Togo in 2008 to that in 2009?
Give a very brief answer. 0.87. What is the ratio of the Expenses (% of total expenses) of High income in 2008 to that in 2010?
Offer a terse response. 1.17. What is the ratio of the Expenses (% of total expenses) in Greece in 2008 to that in 2010?
Offer a very short reply. 1.01. What is the ratio of the Expenses (% of total expenses) in Togo in 2008 to that in 2010?
Your response must be concise. 0.97. What is the ratio of the Expenses (% of total expenses) in Tunisia in 2008 to that in 2010?
Your response must be concise. 1.01. What is the ratio of the Expenses (% of total expenses) of High income in 2008 to that in 2011?
Offer a very short reply. 1.17. What is the ratio of the Expenses (% of total expenses) in Greece in 2008 to that in 2011?
Ensure brevity in your answer.  1.08. What is the ratio of the Expenses (% of total expenses) in Togo in 2008 to that in 2011?
Your response must be concise. 0.93. What is the ratio of the Expenses (% of total expenses) in Tunisia in 2008 to that in 2011?
Offer a terse response. 1. What is the ratio of the Expenses (% of total expenses) of High income in 2009 to that in 2010?
Your response must be concise. 1.09. What is the ratio of the Expenses (% of total expenses) in Greece in 2009 to that in 2010?
Keep it short and to the point. 1.04. What is the ratio of the Expenses (% of total expenses) of Togo in 2009 to that in 2010?
Give a very brief answer. 1.1. What is the ratio of the Expenses (% of total expenses) of Tunisia in 2009 to that in 2010?
Ensure brevity in your answer.  1.01. What is the ratio of the Expenses (% of total expenses) in High income in 2009 to that in 2011?
Provide a short and direct response. 1.09. What is the ratio of the Expenses (% of total expenses) of Greece in 2009 to that in 2011?
Your answer should be very brief. 1.1. What is the ratio of the Expenses (% of total expenses) in Togo in 2009 to that in 2011?
Provide a short and direct response. 1.06. What is the ratio of the Expenses (% of total expenses) of Tunisia in 2009 to that in 2011?
Give a very brief answer. 1. What is the ratio of the Expenses (% of total expenses) in High income in 2010 to that in 2011?
Ensure brevity in your answer.  1. What is the ratio of the Expenses (% of total expenses) of Greece in 2010 to that in 2011?
Offer a very short reply. 1.06. What is the difference between the highest and the second highest Expenses (% of total expenses) of High income?
Offer a terse response. 0.03. What is the difference between the highest and the second highest Expenses (% of total expenses) of Greece?
Keep it short and to the point. 1.19. What is the difference between the highest and the second highest Expenses (% of total expenses) of Togo?
Your answer should be compact. 2.39. What is the difference between the highest and the second highest Expenses (% of total expenses) of Tunisia?
Ensure brevity in your answer.  0.1. What is the difference between the highest and the lowest Expenses (% of total expenses) of High income?
Provide a succinct answer. 2.63. What is the difference between the highest and the lowest Expenses (% of total expenses) of Greece?
Your answer should be very brief. 3.68. What is the difference between the highest and the lowest Expenses (% of total expenses) in Togo?
Ensure brevity in your answer.  10.53. What is the difference between the highest and the lowest Expenses (% of total expenses) of Tunisia?
Provide a succinct answer. 4.32. 